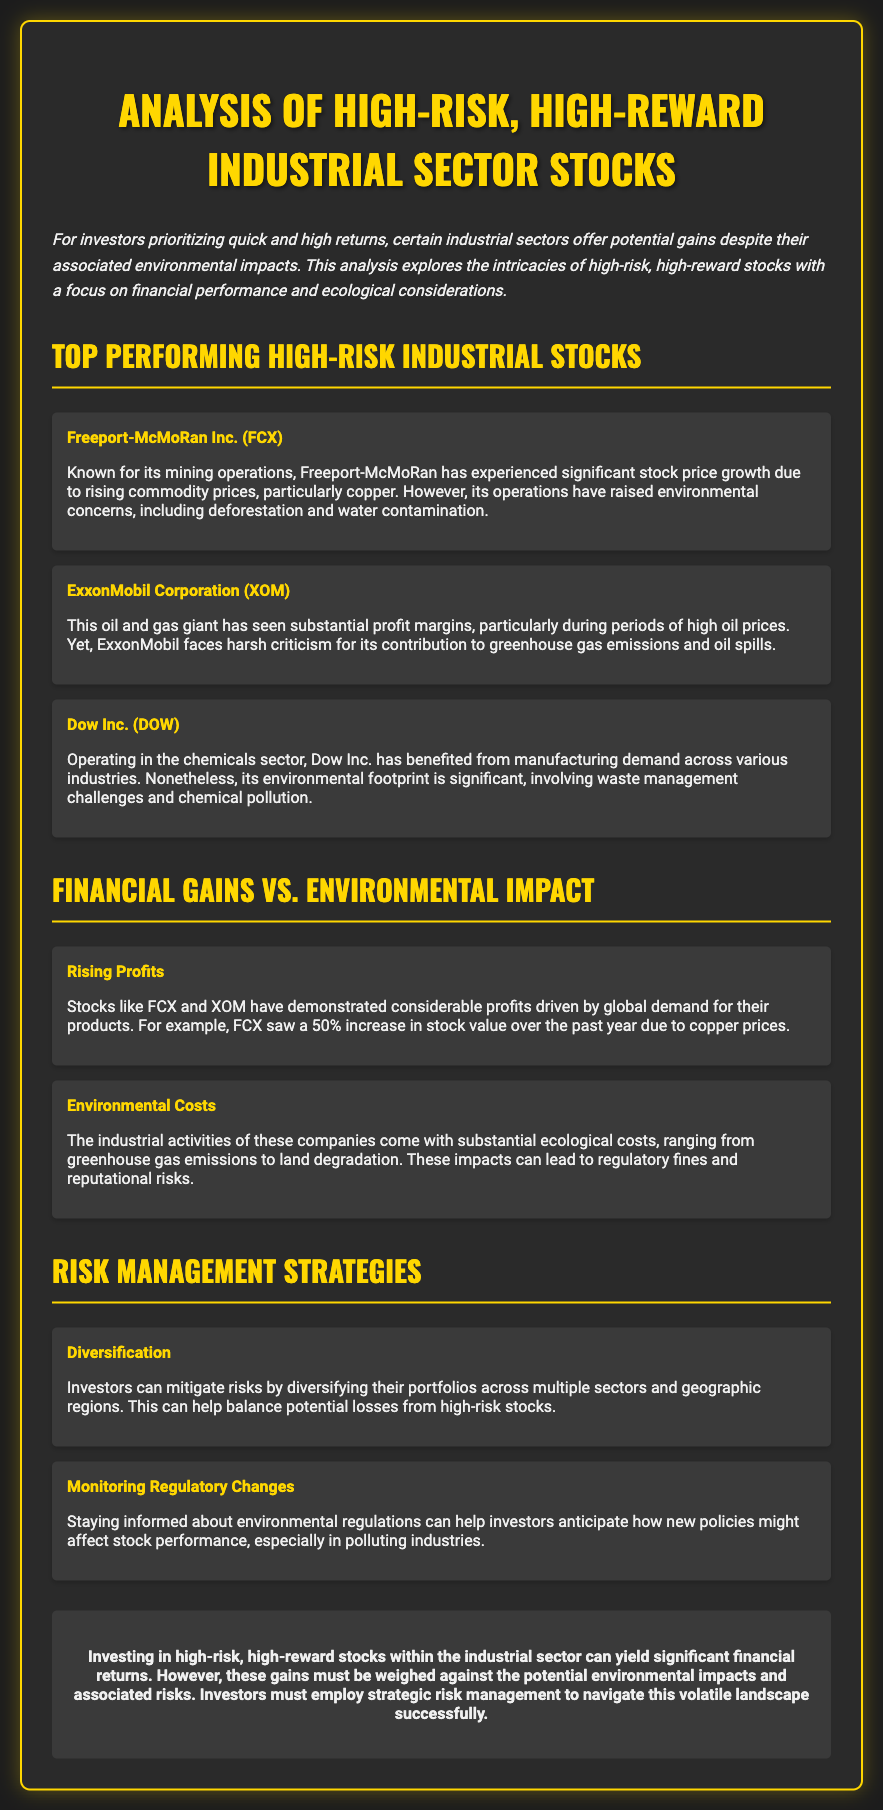what is the title of the analysis? The title is prominently displayed at the top of the document, summarizing the focus of the content.
Answer: Analysis of High-Risk, High-Reward Industrial Sector Stocks who is the first stock listed in the top performing section? The answer is found in the list of stocks provided in the document, specifically the first item under the top-performing section.
Answer: Freeport-McMoRan Inc. (FCX) what percentage increase did FCX see in stock value over the past year? The document mentions specific financial performance metrics for FCX, including its stock value increase.
Answer: 50% what environmental concern is associated with ExxonMobil? The document outlines specific environmental issues related to each company, specifically ExxonMobil.
Answer: greenhouse gas emissions which risk management strategy involves spreading investments across sectors? The document provides various strategies for managing investment risks, specifically one related to diversification.
Answer: Diversification what is the primary theme of the conclusion? The conclusion summarizes the main message of the analysis, reflecting on the balance between risks and rewards in investing.
Answer: financial returns what type of companies are primarily analyzed in this document? The document categorizes companies based on their industry and the risks they embody, specifically referring to their market position.
Answer: industrial sector stocks what color is predominantly used for headings in the document? By observing the style information for the headings, one can identify the specific color choice used for emphasis.
Answer: gold 